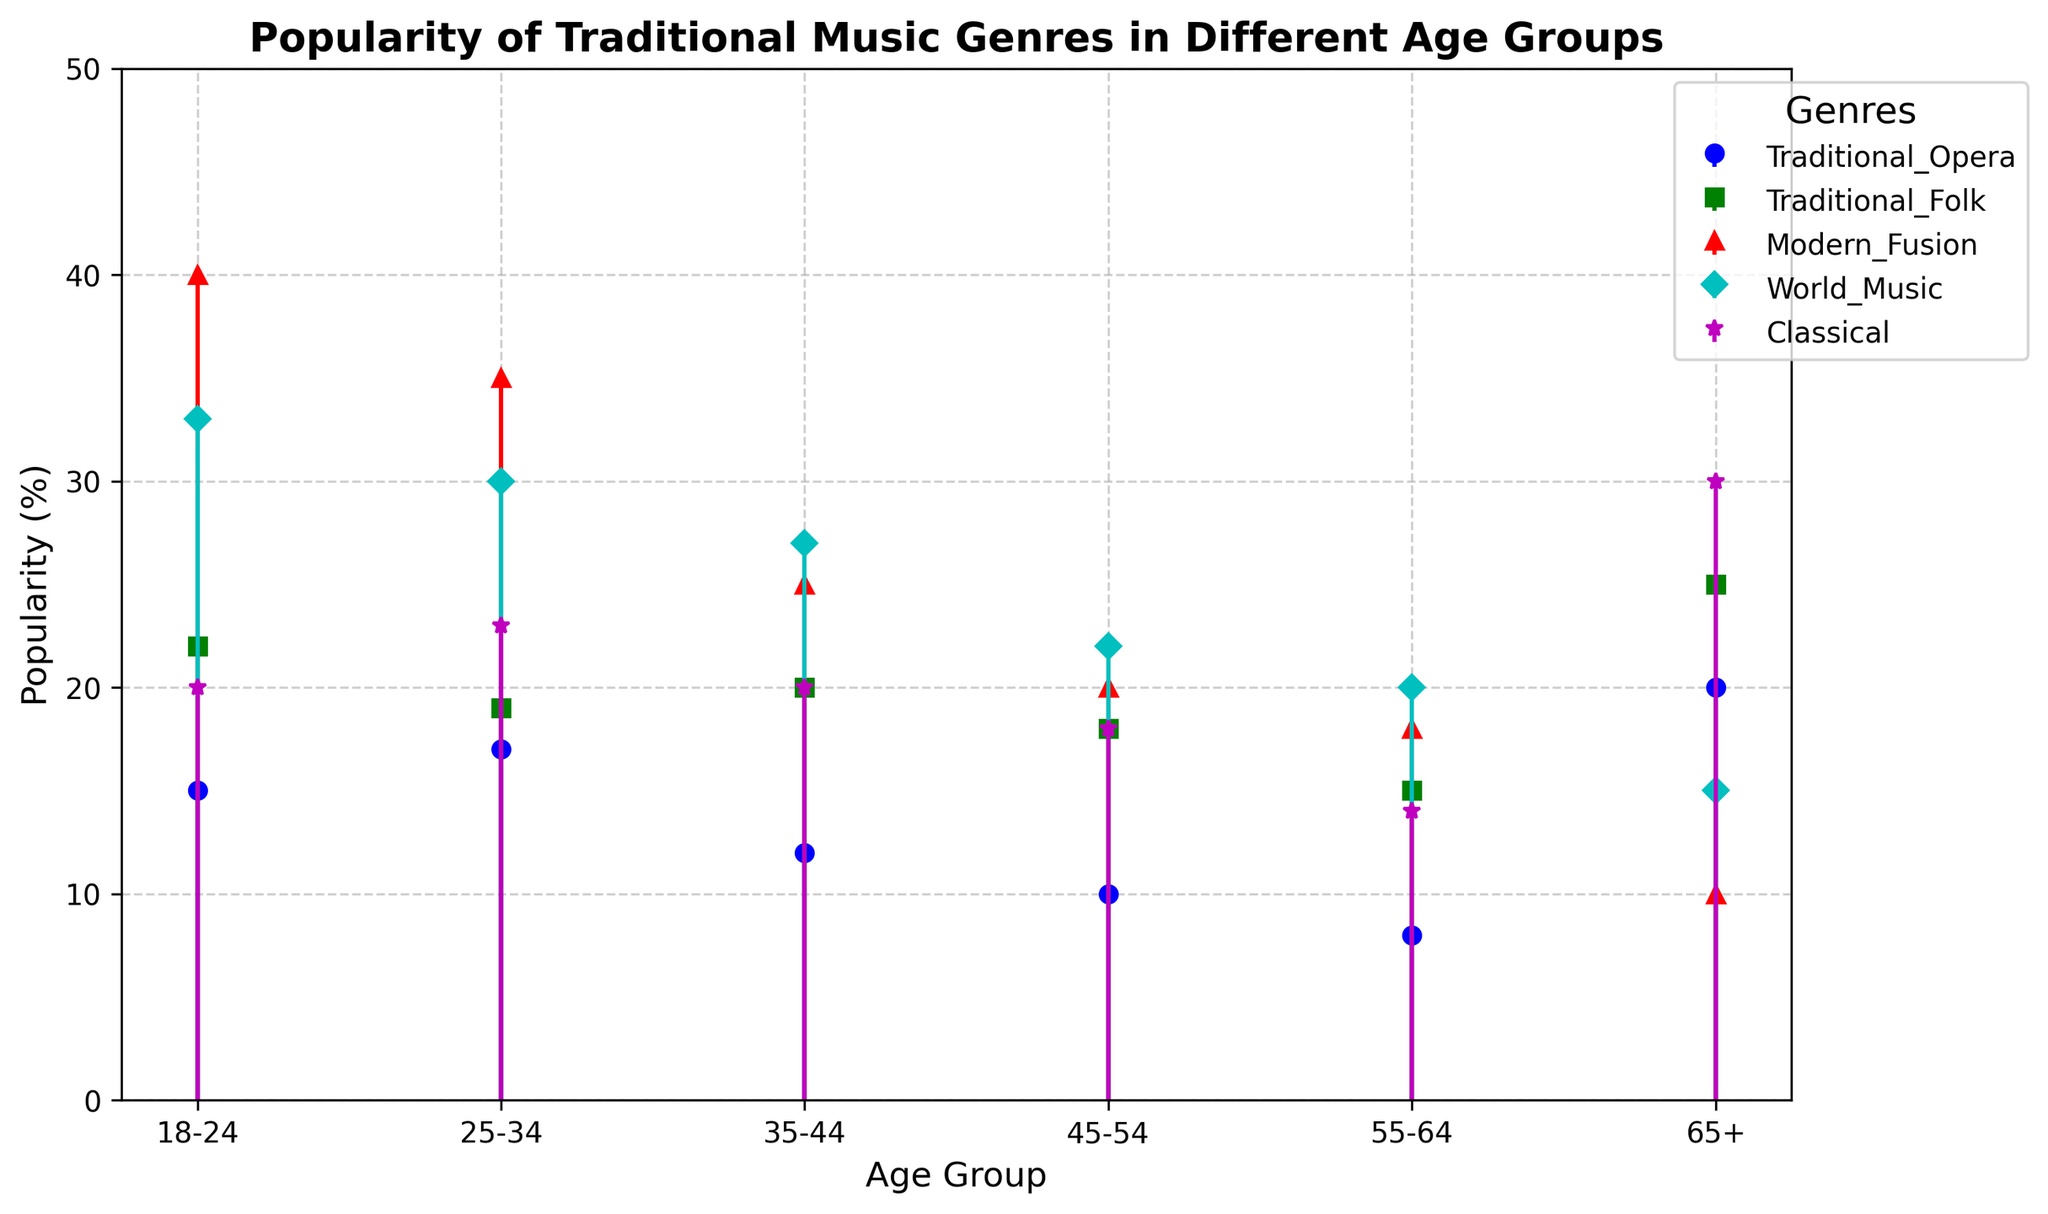What's the trend in the popularity of World Music across the different age groups? Looking at the blue lines for World Music, they start high at 33% in the 18-24 age group and then decrease gradually through the younger age groups, from 30% in the 25-34 age group to 15% in the 65+ group. Overall, the trend is a decrease in popularity with age.
Answer: A decrease in popularity with age How does the popularity of Traditional Opera compare between the 18-24 and 65+ age groups? Traditional Opera has a blue circle-marker line. It shows a significant difference where the 18-24 age group has 15%, while the 65+ age group has 20%, indicating that Traditional Opera becomes more popular in the older age group.
Answer: The 65+ age group Which age group has the highest popularity for Modern Fusion music? Looking at the red triangle marker line for Modern Fusion, the highest point is at the age group 18-24 with 40%. Therefore, the 18-24 age group has the highest popularity for Modern Fusion music.
Answer: 18-24 Which two age groups have the closest popularity percentages for Classical music, and what are those percentages? The purple star line for Classical music shows that the percentages in the 18-24 and 35-44 age groups are both 20%. These two age groups have the closest values.
Answer: 18-24 and 35-44, both 20% What is the average popularity percentage for Traditional Folk across all age groups? Sum up the percentages for Traditional Folk: 22 + 19 + 20 + 18 + 15 + 25 = 119. There are 6 age groups, so the average is 119 / 6 = 19.83%.
Answer: 19.83% In which age group does the popularity of World Music drop the most compared to the previous age group? The blue diamond-marker line for World Music has the most significant drop between the 18-24 age group (33%) and the 25-34 age group (30%), showing a drop of 3%.
Answer: Between 18-24 and 25-34 Calculate the difference in popularity of Traditional Opera between the youngest and oldest age groups. Traditional Opera is represented by the blue circles, with values of 15% for the youngest (18-24) and 20% for the oldest (65+). The difference is 20% - 15% = 5%.
Answer: 5% Which genre shows the steepest decline in popularity as age increases from 18-24 to 65+? Reviewing all lines, the red triangle for Modern Fusion has the steepest decline from 40% at 18-24 to 10% at 65+, a drop of 30%.
Answer: Modern Fusion What percentage point increase does Traditional Folk music see from the 35-44 age group to the 65+ age group? Traditional Folk music represented by the green square line has 20% in the 35-44 age group and 25% in the 65+ age group. The increase is 25% - 20% = 5%.
Answer: 5% Is there any age group where Traditional Opera is more popular than Modern Fusion? Modern Fusion, marked by red triangles, is consistently more popular than Traditional Opera (blue circles) in all age groups except 65+, where Traditional Opera has 20% and Modern Fusion has 10%.
Answer: Yes, in the 65+ age group 